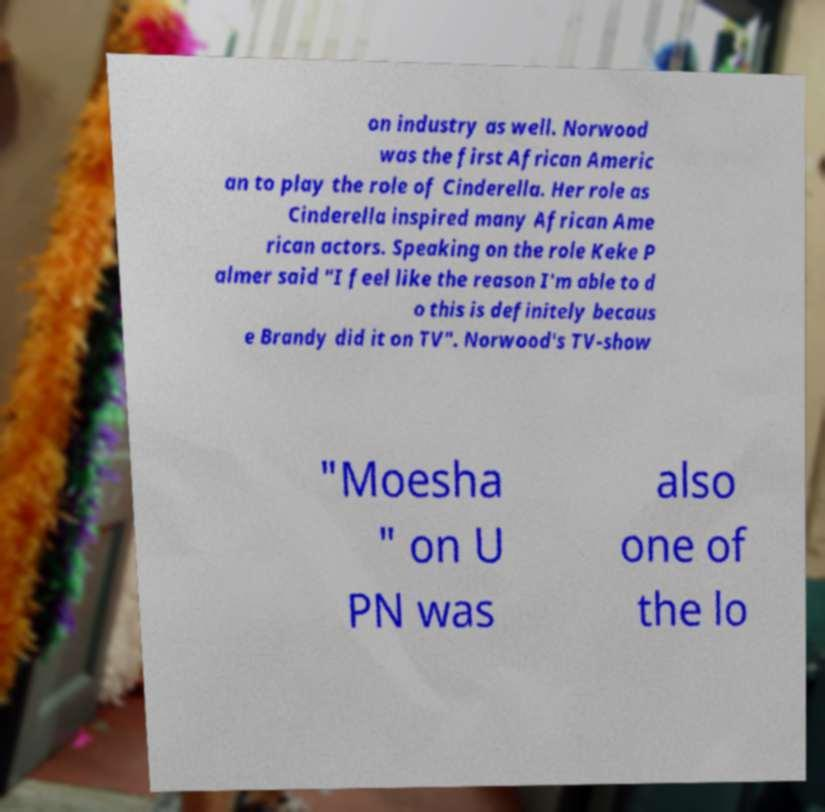There's text embedded in this image that I need extracted. Can you transcribe it verbatim? on industry as well. Norwood was the first African Americ an to play the role of Cinderella. Her role as Cinderella inspired many African Ame rican actors. Speaking on the role Keke P almer said "I feel like the reason I'm able to d o this is definitely becaus e Brandy did it on TV". Norwood's TV-show "Moesha " on U PN was also one of the lo 